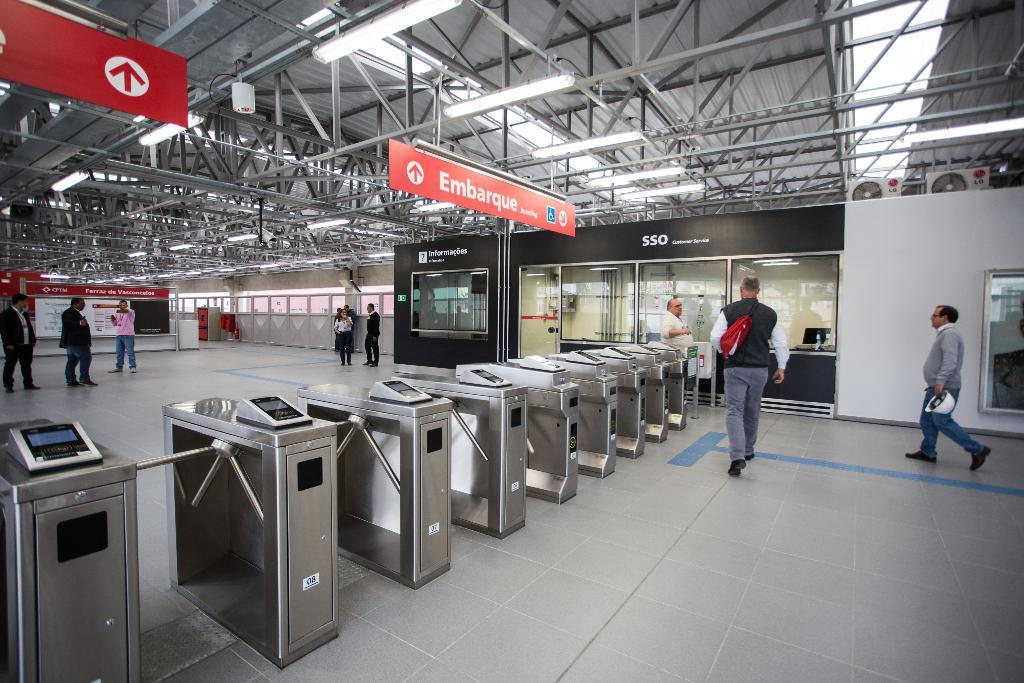<image>
Provide a brief description of the given image. A far away shot of some turnstiles in front of a banner for SSO 